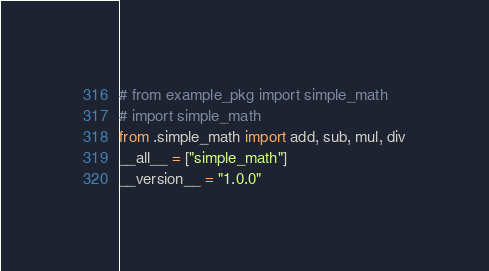Convert code to text. <code><loc_0><loc_0><loc_500><loc_500><_Python_># from example_pkg import simple_math
# import simple_math
from .simple_math import add, sub, mul, div
__all__ = ["simple_math"]
__version__ = "1.0.0"</code> 